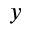Convert formula to latex. <formula><loc_0><loc_0><loc_500><loc_500>y</formula> 